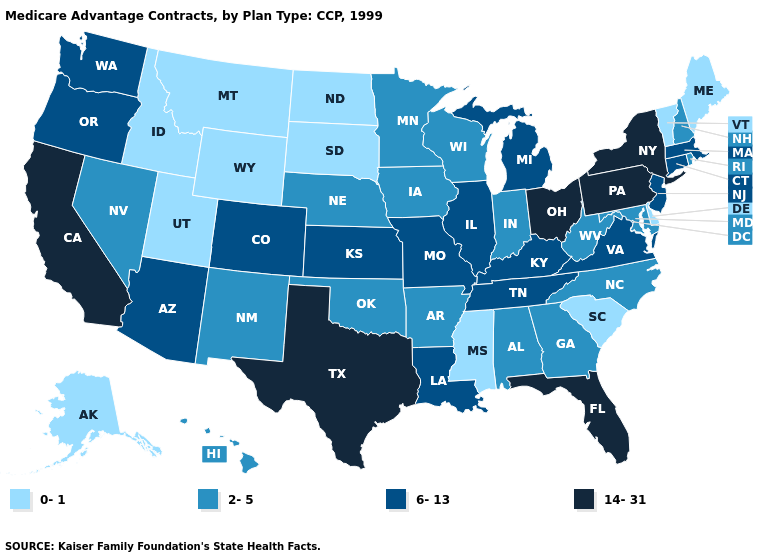What is the highest value in the MidWest ?
Quick response, please. 14-31. Name the states that have a value in the range 6-13?
Be succinct. Arizona, Colorado, Connecticut, Illinois, Kansas, Kentucky, Louisiana, Massachusetts, Michigan, Missouri, New Jersey, Oregon, Tennessee, Virginia, Washington. Which states have the highest value in the USA?
Write a very short answer. California, Florida, New York, Ohio, Pennsylvania, Texas. Among the states that border Ohio , which have the lowest value?
Concise answer only. Indiana, West Virginia. Which states have the lowest value in the West?
Give a very brief answer. Alaska, Idaho, Montana, Utah, Wyoming. What is the value of Mississippi?
Keep it brief. 0-1. What is the value of Oregon?
Concise answer only. 6-13. Does the map have missing data?
Concise answer only. No. Does Maine have the lowest value in the Northeast?
Answer briefly. Yes. Does Rhode Island have the same value as Florida?
Write a very short answer. No. Among the states that border Delaware , does Pennsylvania have the highest value?
Be succinct. Yes. Name the states that have a value in the range 0-1?
Quick response, please. Alaska, Delaware, Idaho, Maine, Mississippi, Montana, North Dakota, South Carolina, South Dakota, Utah, Vermont, Wyoming. Among the states that border Rhode Island , which have the lowest value?
Quick response, please. Connecticut, Massachusetts. Which states hav the highest value in the Northeast?
Concise answer only. New York, Pennsylvania. 